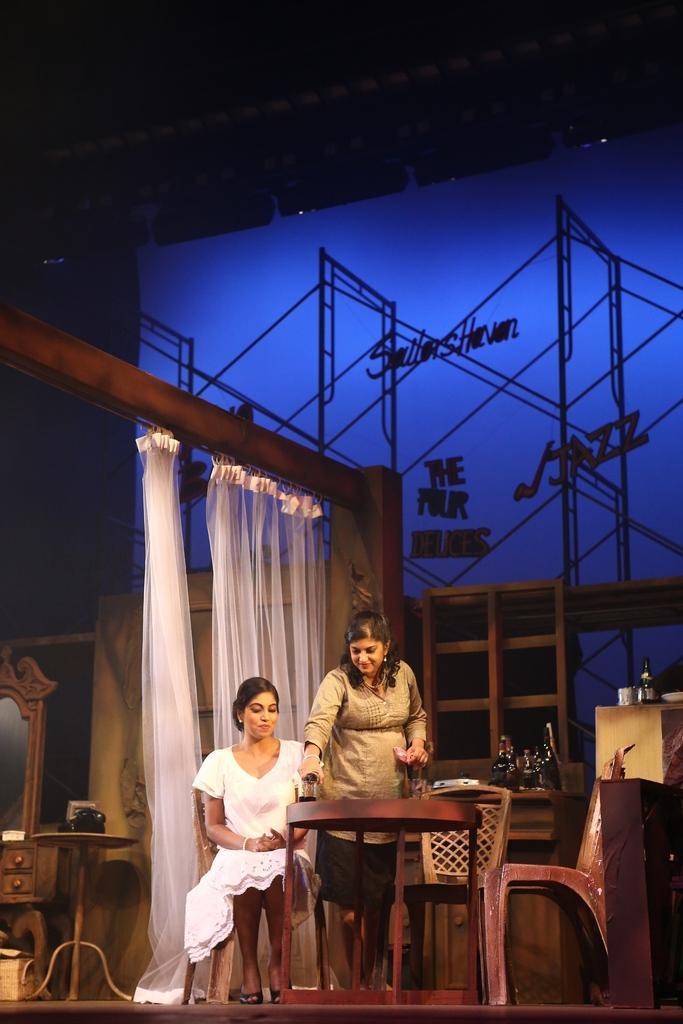In one or two sentences, can you explain what this image depicts? In this picture there are two women one of them is sitting and the other one is having beer and chairs in the backdrop this the curtain, on to the left and there is a blue light on the wall 